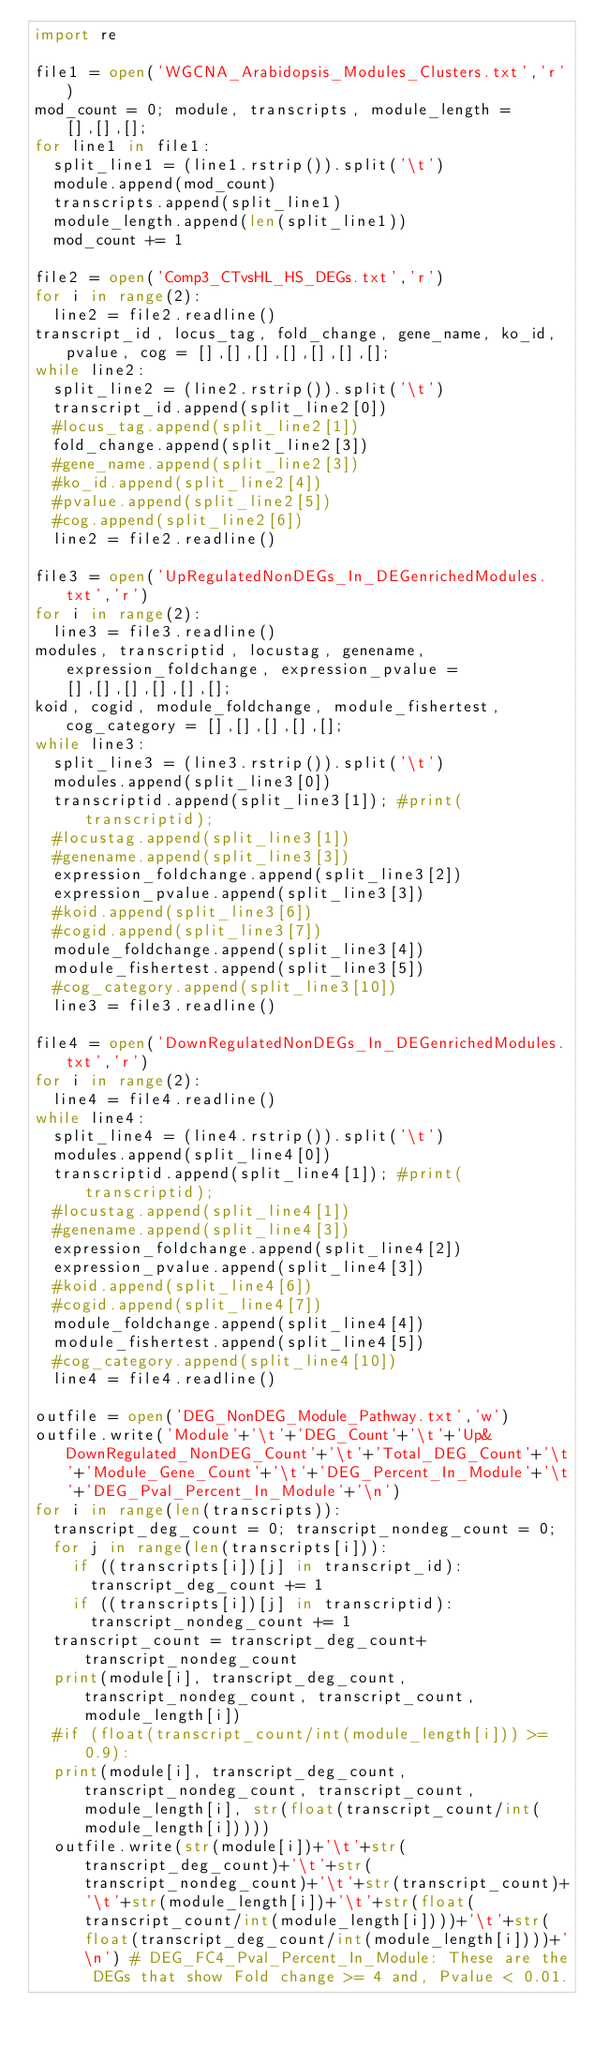Convert code to text. <code><loc_0><loc_0><loc_500><loc_500><_Python_>import re

file1 = open('WGCNA_Arabidopsis_Modules_Clusters.txt','r')
mod_count = 0; module, transcripts, module_length = [],[],[];
for line1 in file1:
	split_line1 = (line1.rstrip()).split('\t')
	module.append(mod_count)
	transcripts.append(split_line1)
	module_length.append(len(split_line1))
	mod_count += 1

file2 = open('Comp3_CTvsHL_HS_DEGs.txt','r')
for i in range(2):
	line2 = file2.readline()
transcript_id, locus_tag, fold_change, gene_name, ko_id, pvalue, cog = [],[],[],[],[],[],[];
while line2:
	split_line2 = (line2.rstrip()).split('\t')
	transcript_id.append(split_line2[0])
	#locus_tag.append(split_line2[1])
	fold_change.append(split_line2[3])
	#gene_name.append(split_line2[3])
	#ko_id.append(split_line2[4])
	#pvalue.append(split_line2[5])
	#cog.append(split_line2[6])
	line2 = file2.readline()

file3 = open('UpRegulatedNonDEGs_In_DEGenrichedModules.txt','r')
for i in range(2):
	line3 = file3.readline()
modules, transcriptid, locustag, genename, expression_foldchange, expression_pvalue = [],[],[],[],[],[];
koid, cogid, module_foldchange, module_fishertest, cog_category = [],[],[],[],[];
while line3:
	split_line3 = (line3.rstrip()).split('\t')
	modules.append(split_line3[0])
	transcriptid.append(split_line3[1]); #print(transcriptid);
	#locustag.append(split_line3[1])
	#genename.append(split_line3[3])
	expression_foldchange.append(split_line3[2])
	expression_pvalue.append(split_line3[3])
	#koid.append(split_line3[6])
	#cogid.append(split_line3[7])
	module_foldchange.append(split_line3[4])
	module_fishertest.append(split_line3[5])
	#cog_category.append(split_line3[10])
	line3 = file3.readline()

file4 = open('DownRegulatedNonDEGs_In_DEGenrichedModules.txt','r')
for i in range(2):
	line4 = file4.readline()
while line4:
	split_line4 = (line4.rstrip()).split('\t')
	modules.append(split_line4[0])
	transcriptid.append(split_line4[1]); #print(transcriptid);
	#locustag.append(split_line4[1])
	#genename.append(split_line4[3])
	expression_foldchange.append(split_line4[2])
	expression_pvalue.append(split_line4[3])
	#koid.append(split_line4[6])
	#cogid.append(split_line4[7])
	module_foldchange.append(split_line4[4])
	module_fishertest.append(split_line4[5])
	#cog_category.append(split_line4[10])
	line4 = file4.readline()

outfile = open('DEG_NonDEG_Module_Pathway.txt','w')
outfile.write('Module'+'\t'+'DEG_Count'+'\t'+'Up&DownRegulated_NonDEG_Count'+'\t'+'Total_DEG_Count'+'\t'+'Module_Gene_Count'+'\t'+'DEG_Percent_In_Module'+'\t'+'DEG_Pval_Percent_In_Module'+'\n')
for i in range(len(transcripts)):
	transcript_deg_count = 0; transcript_nondeg_count = 0;
	for j in range(len(transcripts[i])):
		if ((transcripts[i])[j] in transcript_id):
			transcript_deg_count += 1
		if ((transcripts[i])[j] in transcriptid):
			transcript_nondeg_count += 1
	transcript_count = transcript_deg_count+transcript_nondeg_count
	print(module[i], transcript_deg_count, transcript_nondeg_count, transcript_count, module_length[i])
	#if (float(transcript_count/int(module_length[i])) >= 0.9):
	print(module[i], transcript_deg_count, transcript_nondeg_count, transcript_count, module_length[i], str(float(transcript_count/int(module_length[i]))))
	outfile.write(str(module[i])+'\t'+str(transcript_deg_count)+'\t'+str(transcript_nondeg_count)+'\t'+str(transcript_count)+'\t'+str(module_length[i])+'\t'+str(float(transcript_count/int(module_length[i])))+'\t'+str(float(transcript_deg_count/int(module_length[i])))+'\n') # DEG_FC4_Pval_Percent_In_Module: These are the DEGs that show Fold change >= 4 and, Pvalue < 0.01.




</code> 